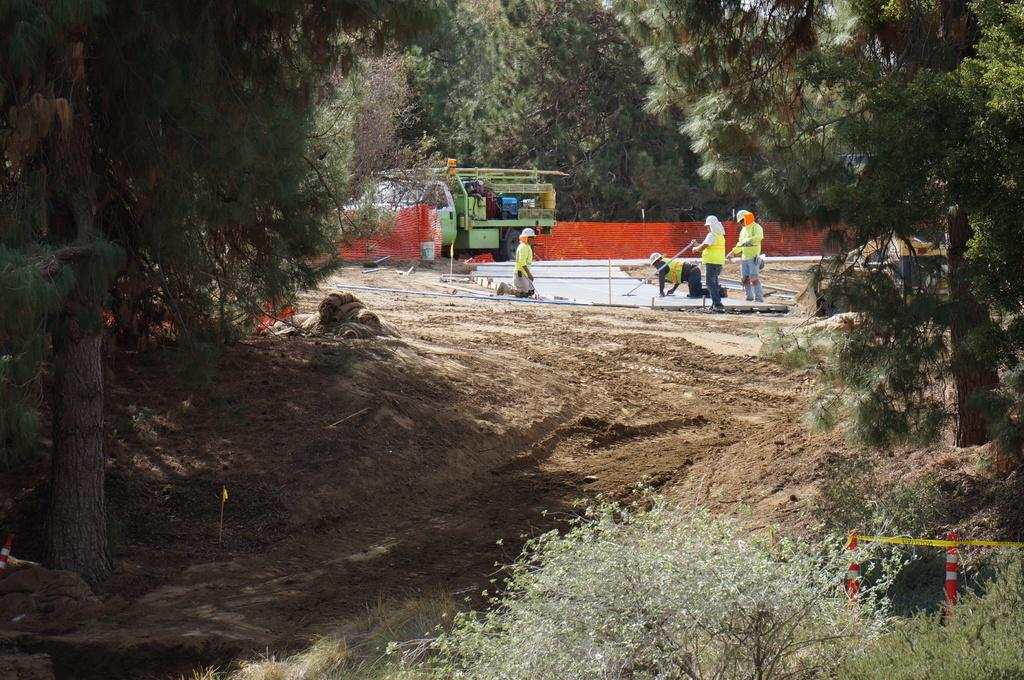How many people are in the image? There are people in the image, but the exact number is not specified. What type of vehicle is in the image? There is a vehicle in the image, but the specific type is not mentioned. What are the poles used for in the image? The purpose of the poles in the image is not clear from the provided facts. What is the ribbon used for in the image? The purpose of the ribbon in the image is not clear from the provided facts. What type of trees and plants are in the image? The specific types of trees and plants in the image are not mentioned. What is visible in the sky in the image? The sky is visible in the image, but the specific weather or time of day is not mentioned. What is the tendency of the deer to move around in the image? There are no deer present in the image, so it is not possible to determine their tendency to move around. 